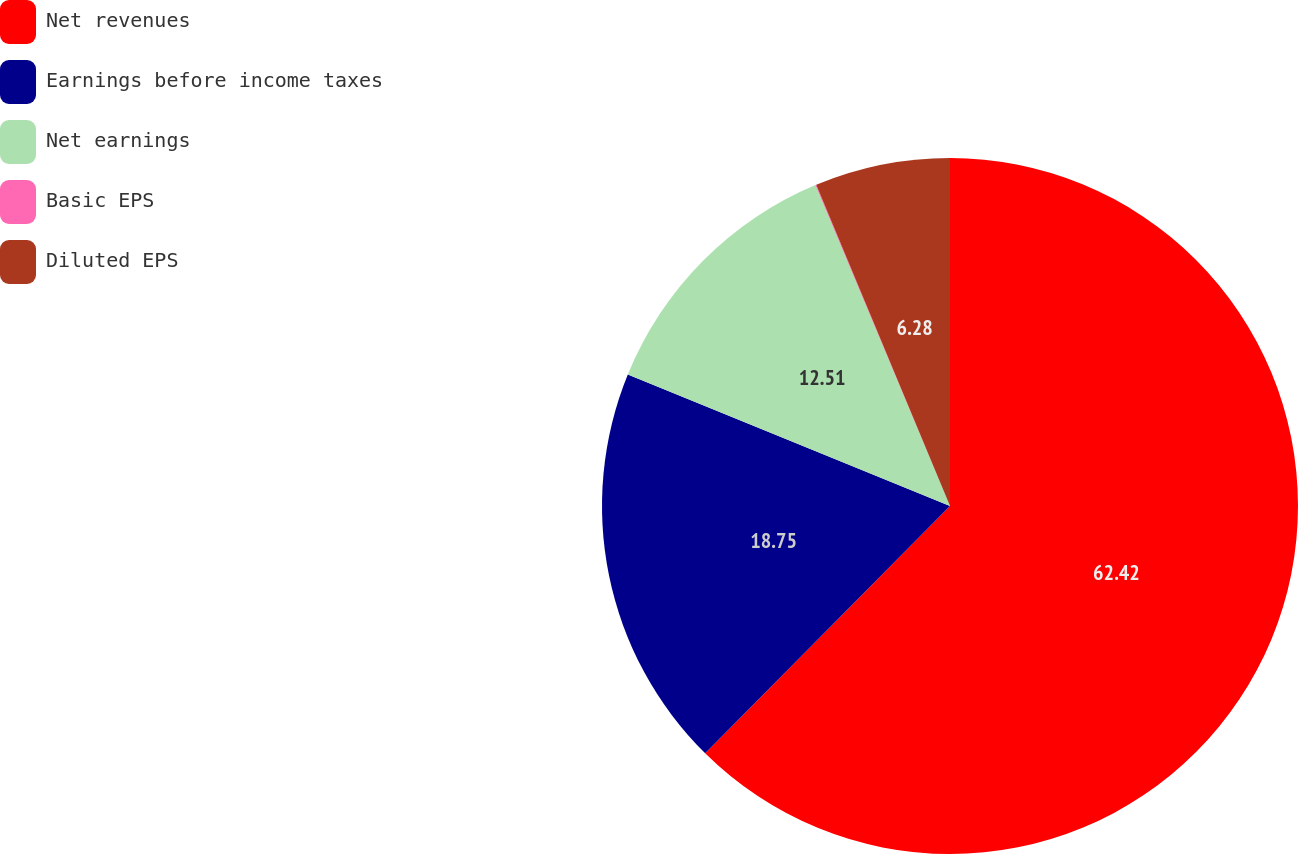<chart> <loc_0><loc_0><loc_500><loc_500><pie_chart><fcel>Net revenues<fcel>Earnings before income taxes<fcel>Net earnings<fcel>Basic EPS<fcel>Diluted EPS<nl><fcel>62.42%<fcel>18.75%<fcel>12.51%<fcel>0.04%<fcel>6.28%<nl></chart> 